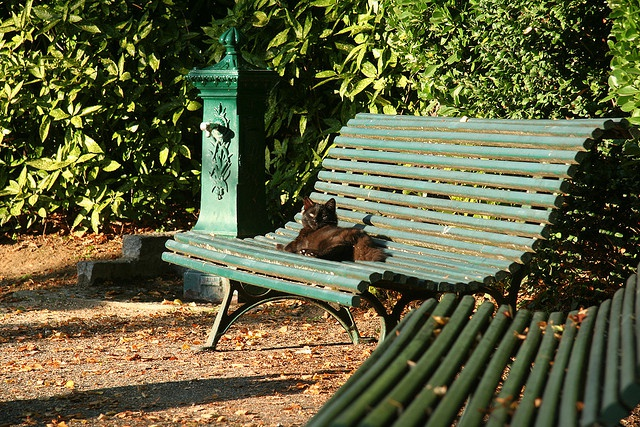Describe the objects in this image and their specific colors. I can see bench in black, darkgray, lightblue, and tan tones, bench in black and darkgreen tones, and cat in black, maroon, and gray tones in this image. 